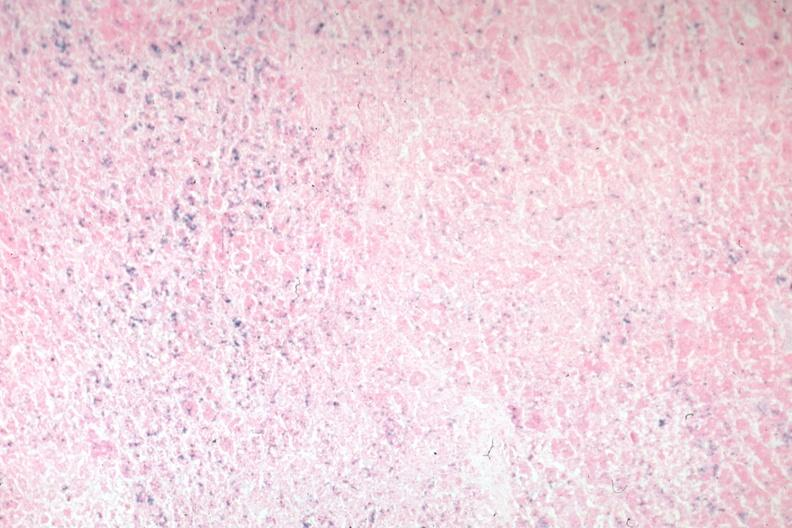s acute peritonitis present?
Answer the question using a single word or phrase. No 